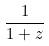Convert formula to latex. <formula><loc_0><loc_0><loc_500><loc_500>\frac { 1 } { 1 + z }</formula> 